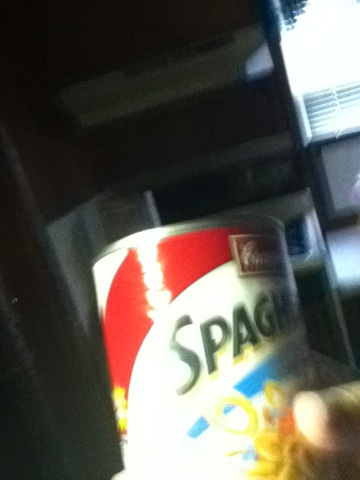What is this can? This is a can of spaghetti. The label indicates that it contains cooked spaghetti noodles, likely in a marinara or similar tomato-based sauce. It's a convenient, ready-to-eat meal that can be easily heated up and served. 